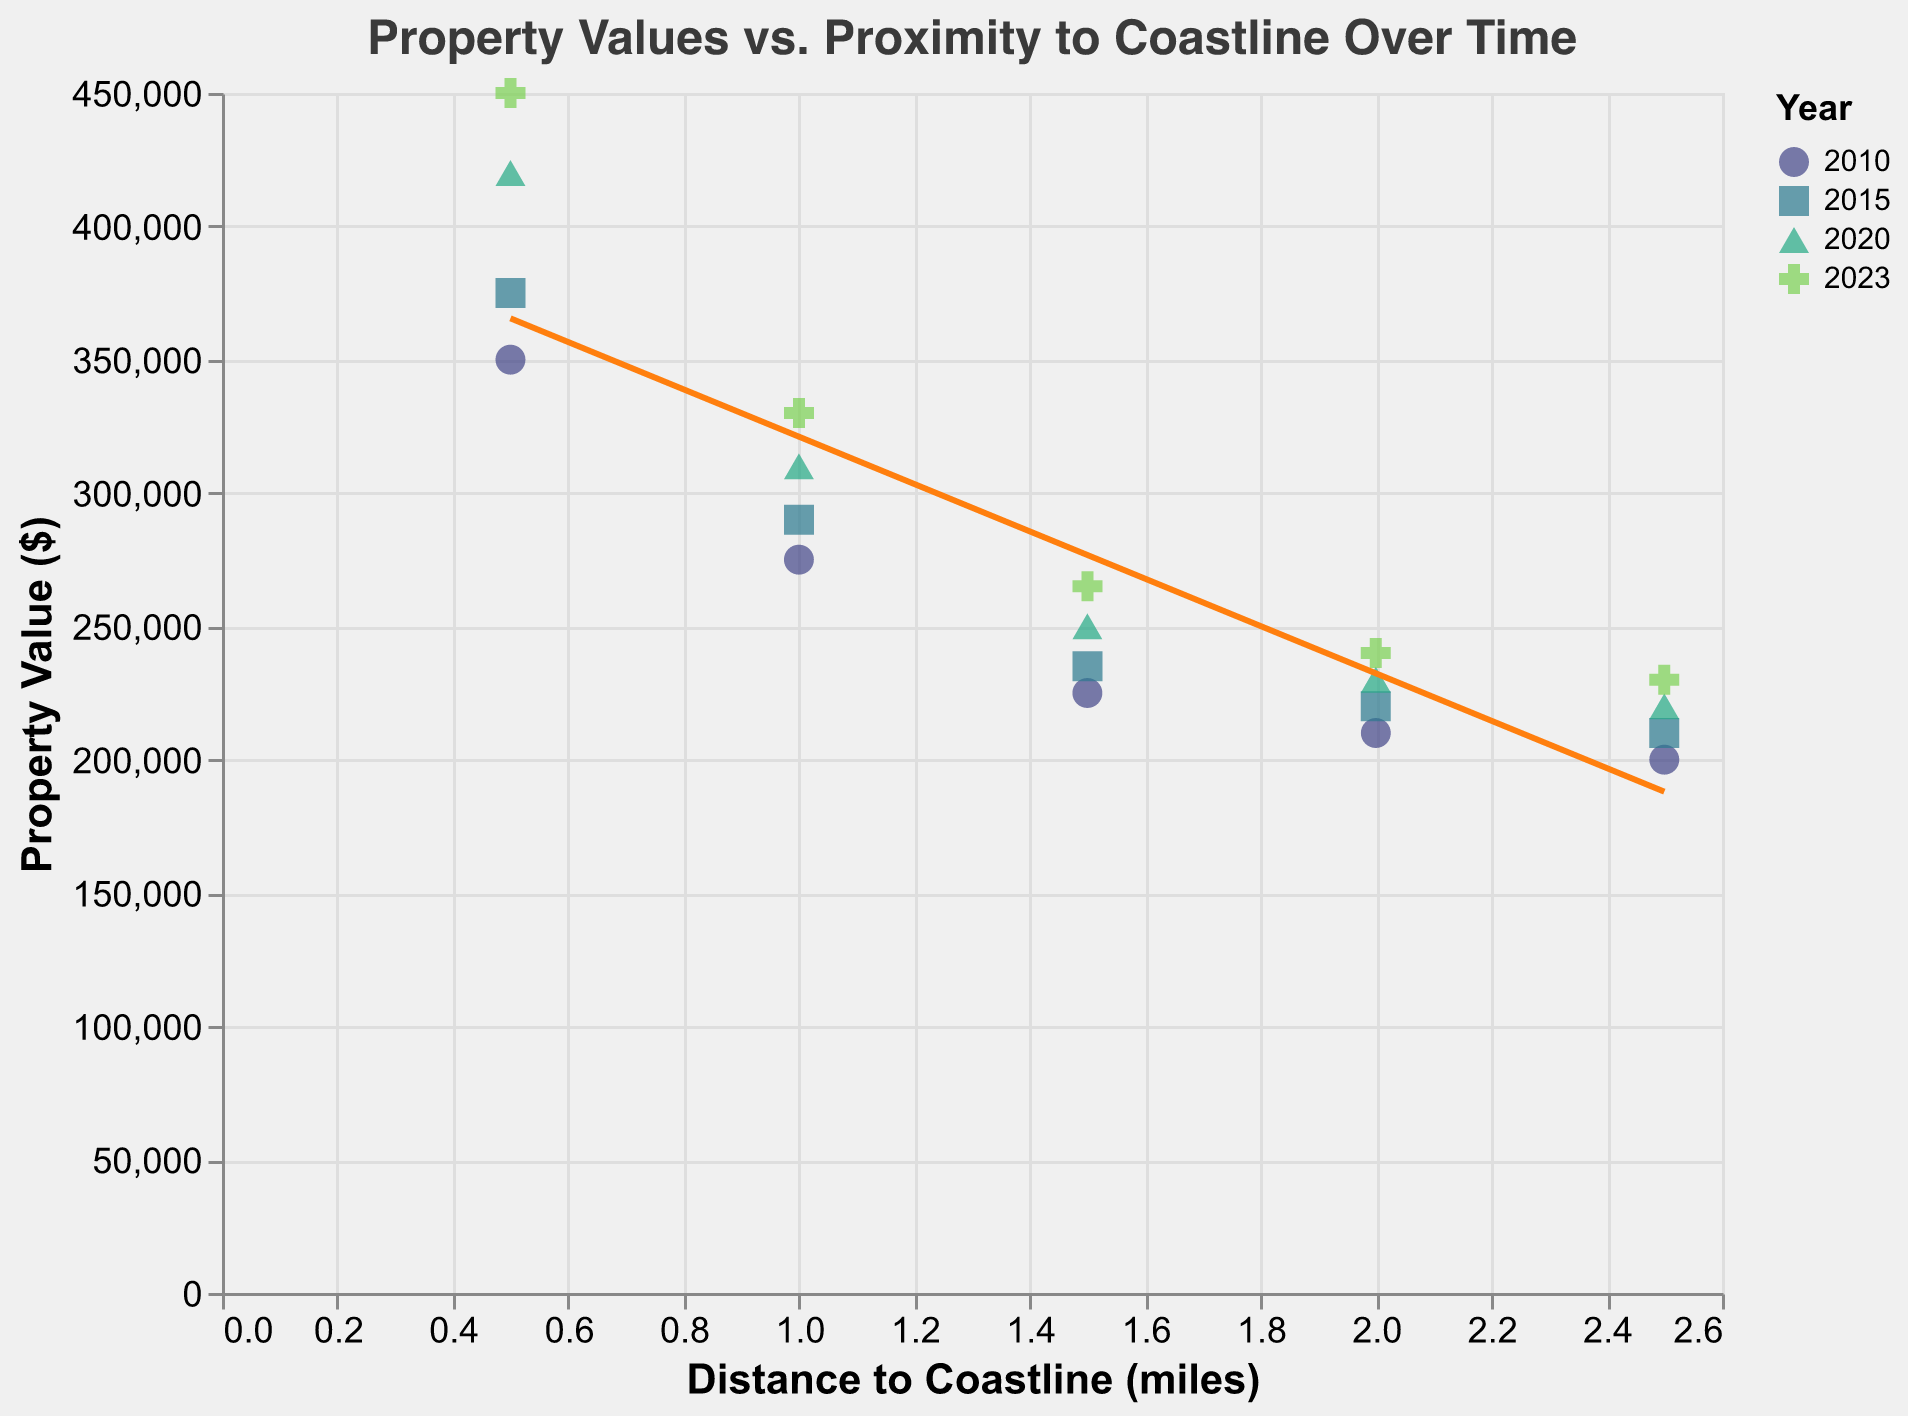What is the title of the figure? The title is displayed prominently at the top of the figure. It reads, "Property Values vs. Proximity to Coastline Over Time."
Answer: Property Values vs. Proximity to Coastline Over Time Which year has the data point with the highest property value? By inspecting the y-axis for Property Value, the data point with the highest property value is $450,000. By referring to the legend, this value corresponds to the year 2023.
Answer: 2023 How does property value change with increasing distance from the coastline? Observing the trend line, property values generally decrease as the distance from the coastline increases. The trend line slopes downward from left to right.
Answer: Decreases What is the average property value for properties 0.5 miles away from the coastline in all available years? Extract the individual property values at 0.5 miles for the years 2010, 2015, 2020, and 2023: 350,000, 375,000, 420,000, and 450,000. The average is calculated as (350000 + 375000 + 420000 + 450000) / 4 = 398750.
Answer: 398,750 Compare the property value in 2020 for a distance of 1.0 miles and 2.0 miles. Which is higher, and by how much? For 2020, the property values at 1.0 miles and 2.0 miles are $310,000 and $230,000, respectively. The value at 1.0 miles is higher by $310,000 - $230,000 = $80,000.
Answer: 1.0 miles, $80,000 What trend can be observed when comparing property values from 2010 to 2023? An upward trend is observed. Property values increase over time, as shown by the  trend line shifting higher on the y-axis for the same distances to the coastline from 2010 to 2023.
Answer: Increasing over time How many different years of data are represented in the figure? Referencing the legend, different colors and shapes represent the years. There are four distinct years: 2010, 2015, 2020, and 2023.
Answer: 4 What is the distance to the coastline where property value remains around $200,000 in 2010? Look at the data points for 2010. The property value near $200,000 is at a distance of 2.5 miles from the coastline.
Answer: 2.5 miles Does the average property value at 2.0 miles from the coastline increase, decrease, or stay the same over the years? Calculate the average property value for 2.0 miles across the years: 2010 ($210,000), 2015 ($220,000), 2020 ($230,000), and 2023 ($240,000). The average property value increases over the years.
Answer: Increases 